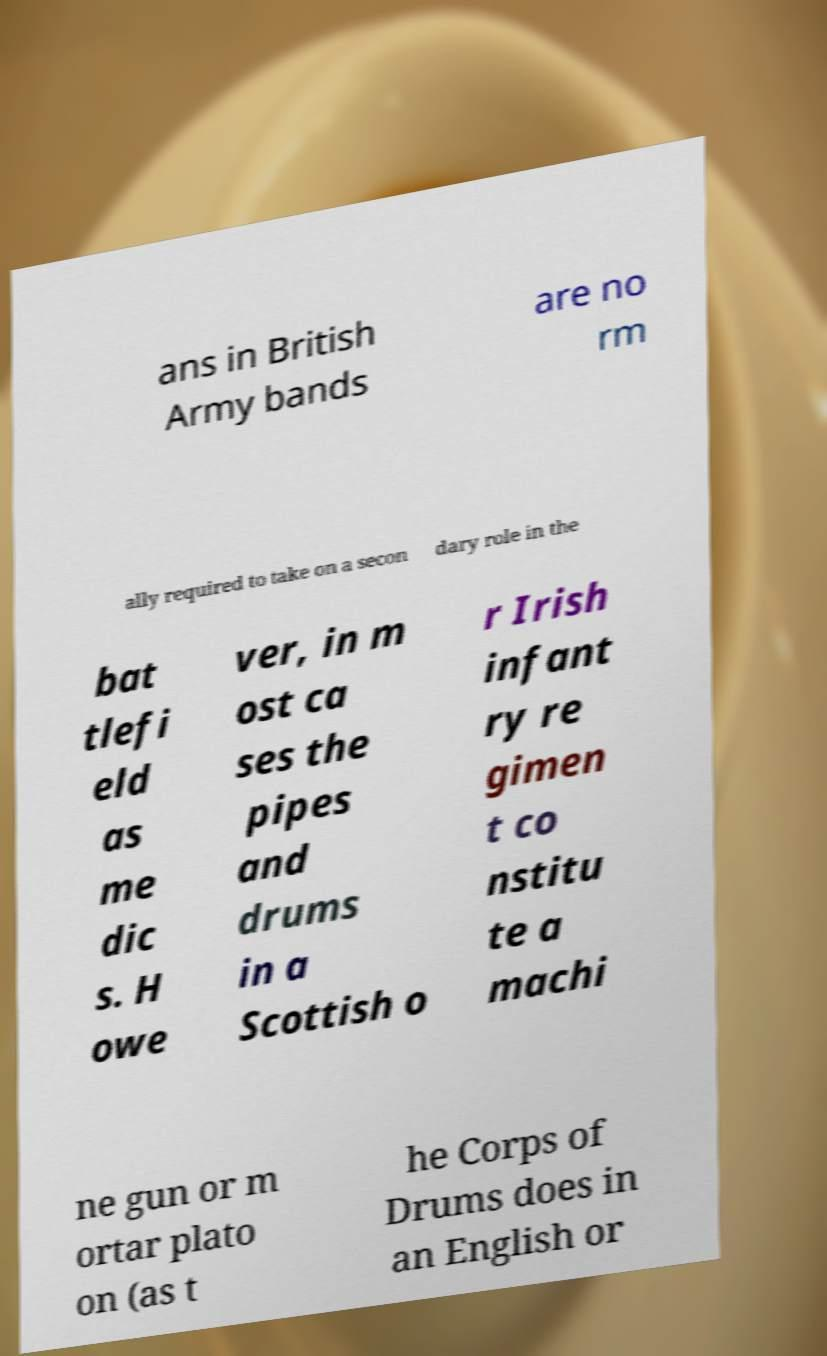Can you accurately transcribe the text from the provided image for me? ans in British Army bands are no rm ally required to take on a secon dary role in the bat tlefi eld as me dic s. H owe ver, in m ost ca ses the pipes and drums in a Scottish o r Irish infant ry re gimen t co nstitu te a machi ne gun or m ortar plato on (as t he Corps of Drums does in an English or 